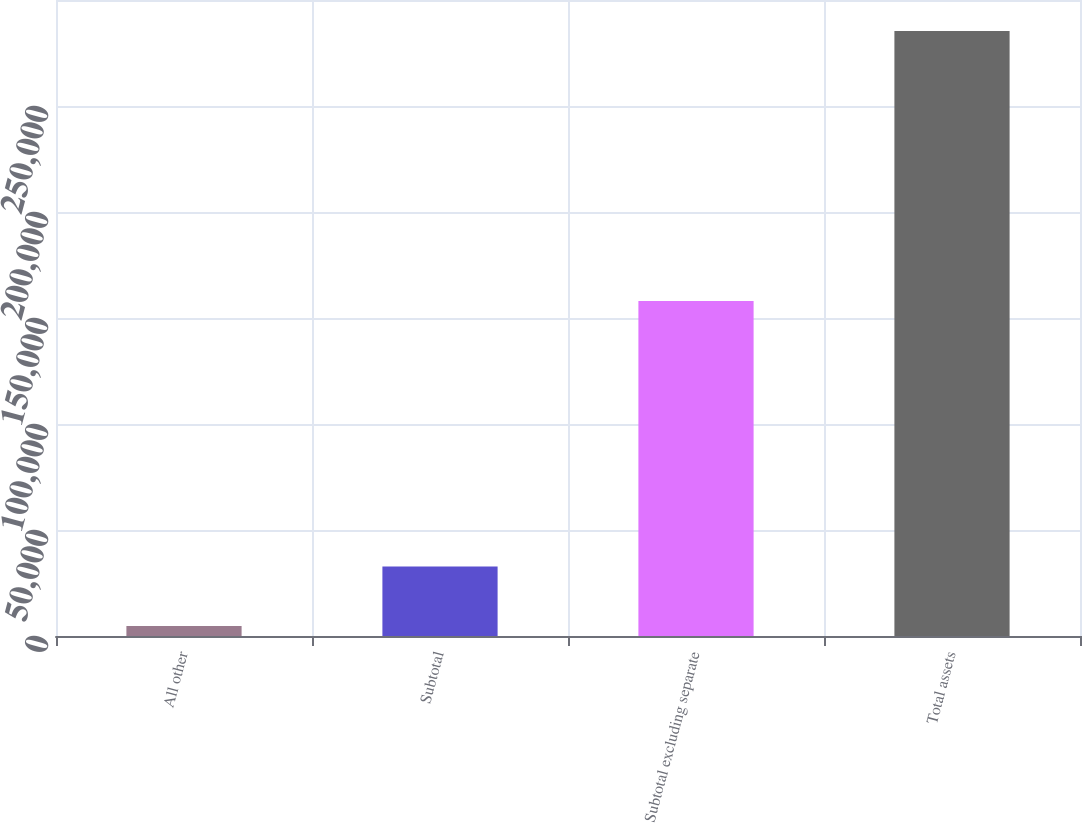Convert chart. <chart><loc_0><loc_0><loc_500><loc_500><bar_chart><fcel>All other<fcel>Subtotal<fcel>Subtotal excluding separate<fcel>Total assets<nl><fcel>4707<fcel>32778.9<fcel>158045<fcel>285426<nl></chart> 